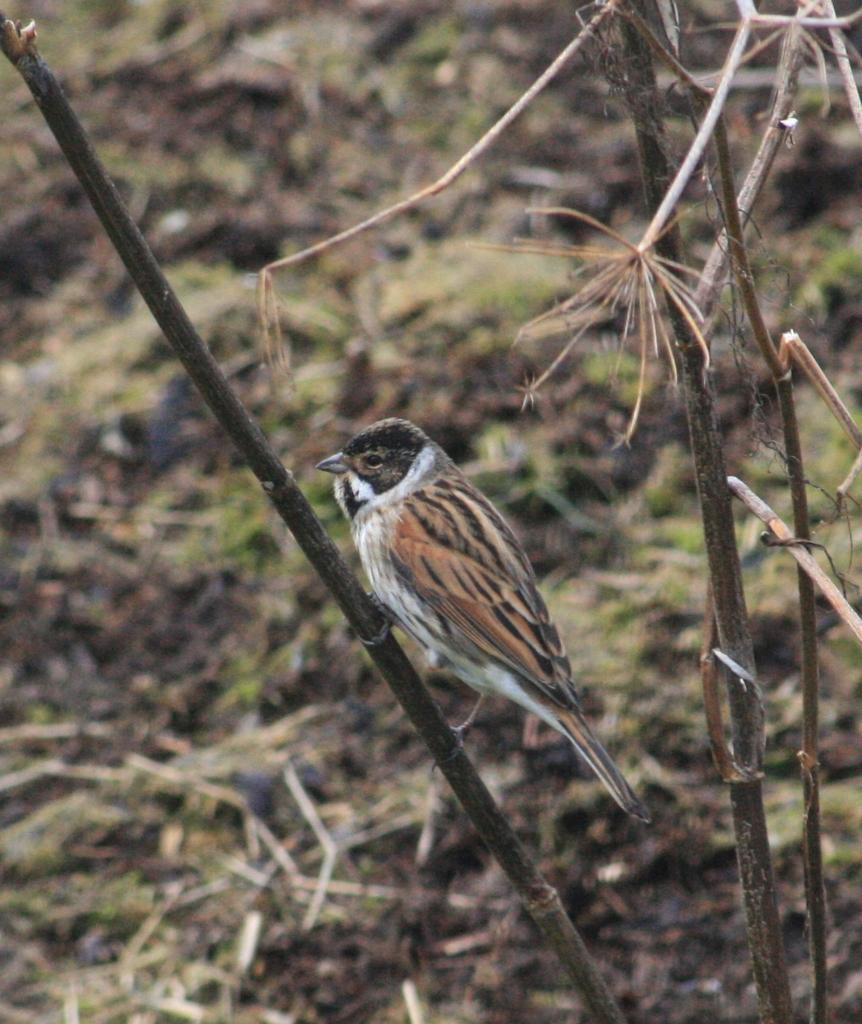What type of animal can be seen in the image? There is a bird in the image. Where is the bird located in the image? The bird is standing on a branch. What can be seen in the background of the image? There is ground visible in the background of the image. What is present on the ground in the background of the image? There are twigs on the ground in the background of the image. What is the value of the bird's angle in the image? The image does not provide information about the bird's angle or any numerical values related to it. 